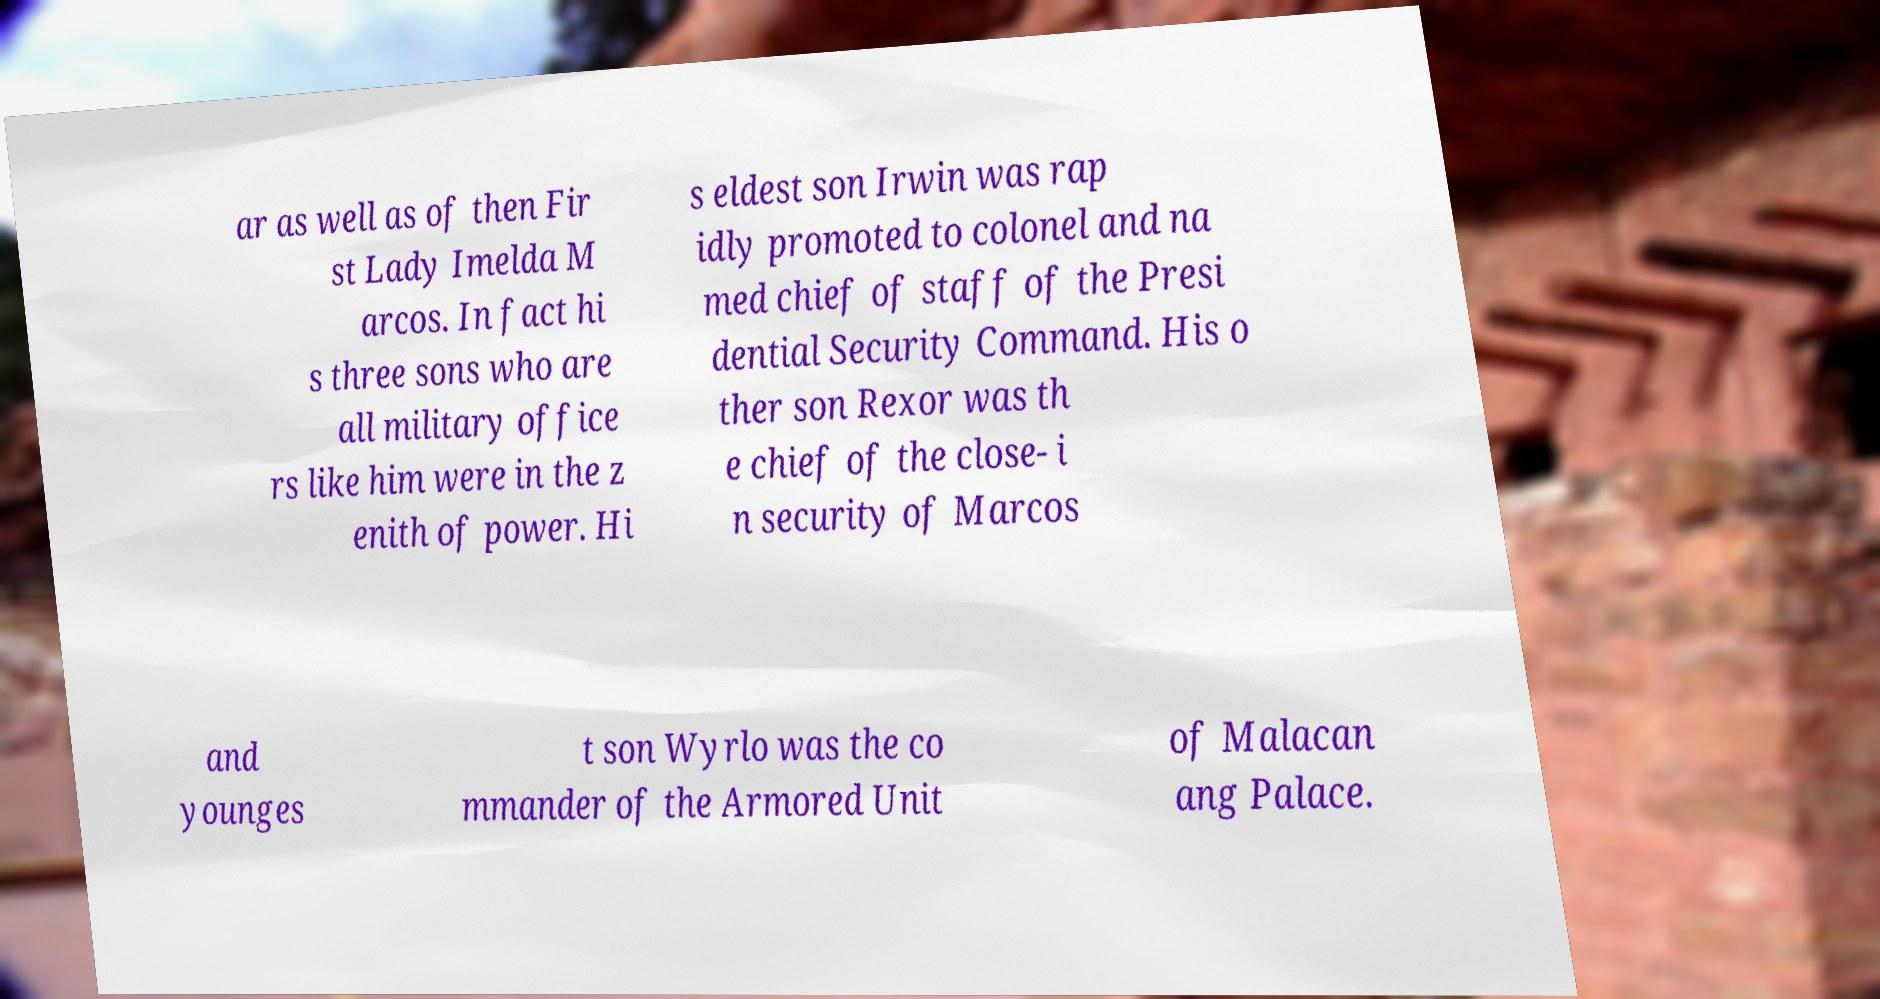Could you extract and type out the text from this image? ar as well as of then Fir st Lady Imelda M arcos. In fact hi s three sons who are all military office rs like him were in the z enith of power. Hi s eldest son Irwin was rap idly promoted to colonel and na med chief of staff of the Presi dential Security Command. His o ther son Rexor was th e chief of the close- i n security of Marcos and younges t son Wyrlo was the co mmander of the Armored Unit of Malacan ang Palace. 